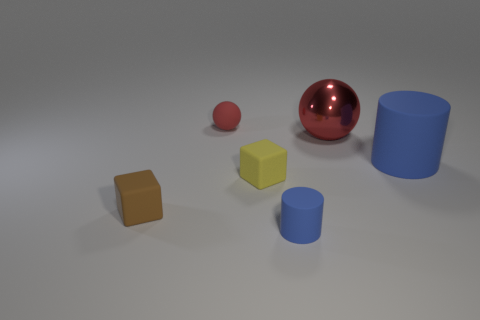Add 2 big cyan shiny cylinders. How many objects exist? 8 Subtract all balls. How many objects are left? 4 Add 4 big blue cylinders. How many big blue cylinders are left? 5 Add 5 tiny cyan metallic balls. How many tiny cyan metallic balls exist? 5 Subtract 0 blue spheres. How many objects are left? 6 Subtract all small things. Subtract all tiny brown rubber spheres. How many objects are left? 2 